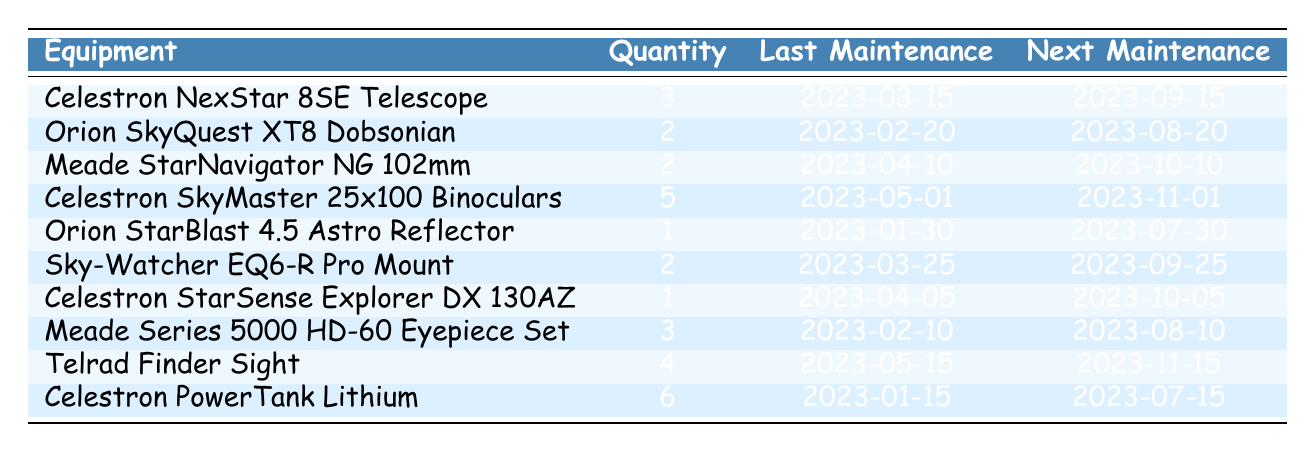What is the quantity of Celestron NexStar 8SE Telescopes? The quantity of Celestron NexStar 8SE Telescopes can be found directly in the table under the "Quantity" column corresponding to the row for that equipment. The value is 3.
Answer: 3 When is the next maintenance for the Orion StarBlast 4.5 Astro Reflector? The next maintenance date for the Orion StarBlast 4.5 Astro Reflector can be found under the "Next Maintenance" column in the row for that equipment. The date is 2023-07-30.
Answer: 2023-07-30 How many total telescopes are listed in the inventory? To find the total number of telescopes, we need to look at the specific types of telescopes in the table: Celestron NexStar 8SE, Orion SkyQuest XT8 Dobsonian, Meade StarNavigator NG 102mm, Orion StarBlast 4.5 Astro Reflector, and Celestron StarSense Explorer DX 130AZ. There are 3 + 2 + 2 + 1 + 1 = 9 telescopes.
Answer: 9 Is there any equipment that has its last maintenance scheduled after 2023-04-01? We need to check the "Last Maintenance" dates for each piece of equipment and see if any are after 2023-04-01. The equipment that meets this criterion includes Celestron NexStar 8SE, Meade StarNavigator NG 102mm, and Celestron SkyMaster 25x100 Binoculars among others. Thus, yes, there are several.
Answer: Yes What equipment has the highest quantity available? To determine which equipment has the highest quantity, we compare the numbers listed under the "Quantity" column. The Celestron PowerTank Lithium has a quantity of 6, which is the highest compared to other equipment.
Answer: Celestron PowerTank Lithium What is the average quantity of all types of stargazing equipment? We need to sum up all the quantities listed in the "Quantity" column and divide by the total number of different types of equipment. The quantities are: 3, 2, 2, 5, 1, 2, 1, 3, 4, 6. Adding them gives 29, and dividing by 10 (the number of equipment types) gives 2.9.
Answer: 2.9 How many pieces of stargazing equipment have a next maintenance date of 2023-10-10? We can scan the "Next Maintenance" column for the date 2023-10-10 and count the matching entries. There is 1 piece of equipment, the Meade StarNavigator NG 102mm, that has this date.
Answer: 1 Is the next maintenance for the Celestron SkyMaster 25x100 Binoculars scheduled before or after 2023-10-01? We refer to the "Next Maintenance" date for the Celestron SkyMaster 25x100 Binoculars. The date is 2023-11-01, which is after 2023-10-01. Therefore, the answer is after.
Answer: After 